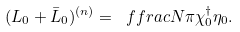Convert formula to latex. <formula><loc_0><loc_0><loc_500><loc_500>( L _ { 0 } + \bar { L } _ { 0 } ) ^ { ( n ) } = \ f f r a c { N } { \pi } \chi ^ { \dagger } _ { 0 } \eta _ { 0 } .</formula> 